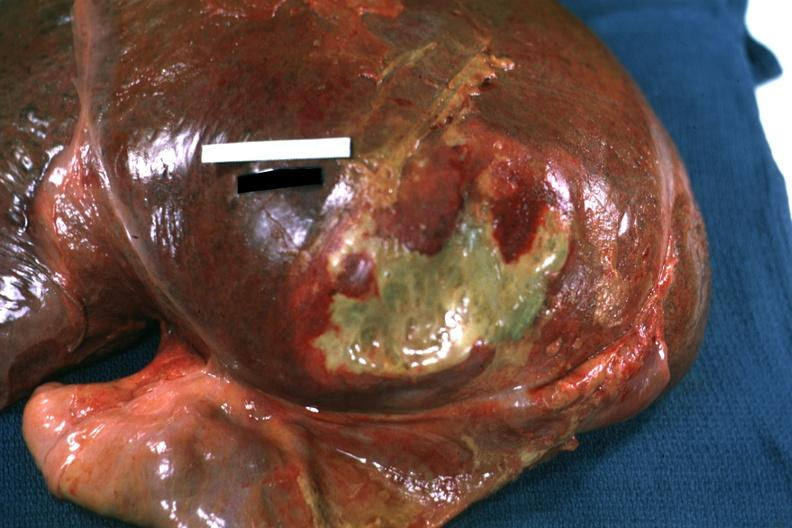how is right leaf of diaphragm reflected to show mass of yellow green pus quite good example?
Answer the question using a single word or phrase. Flat 